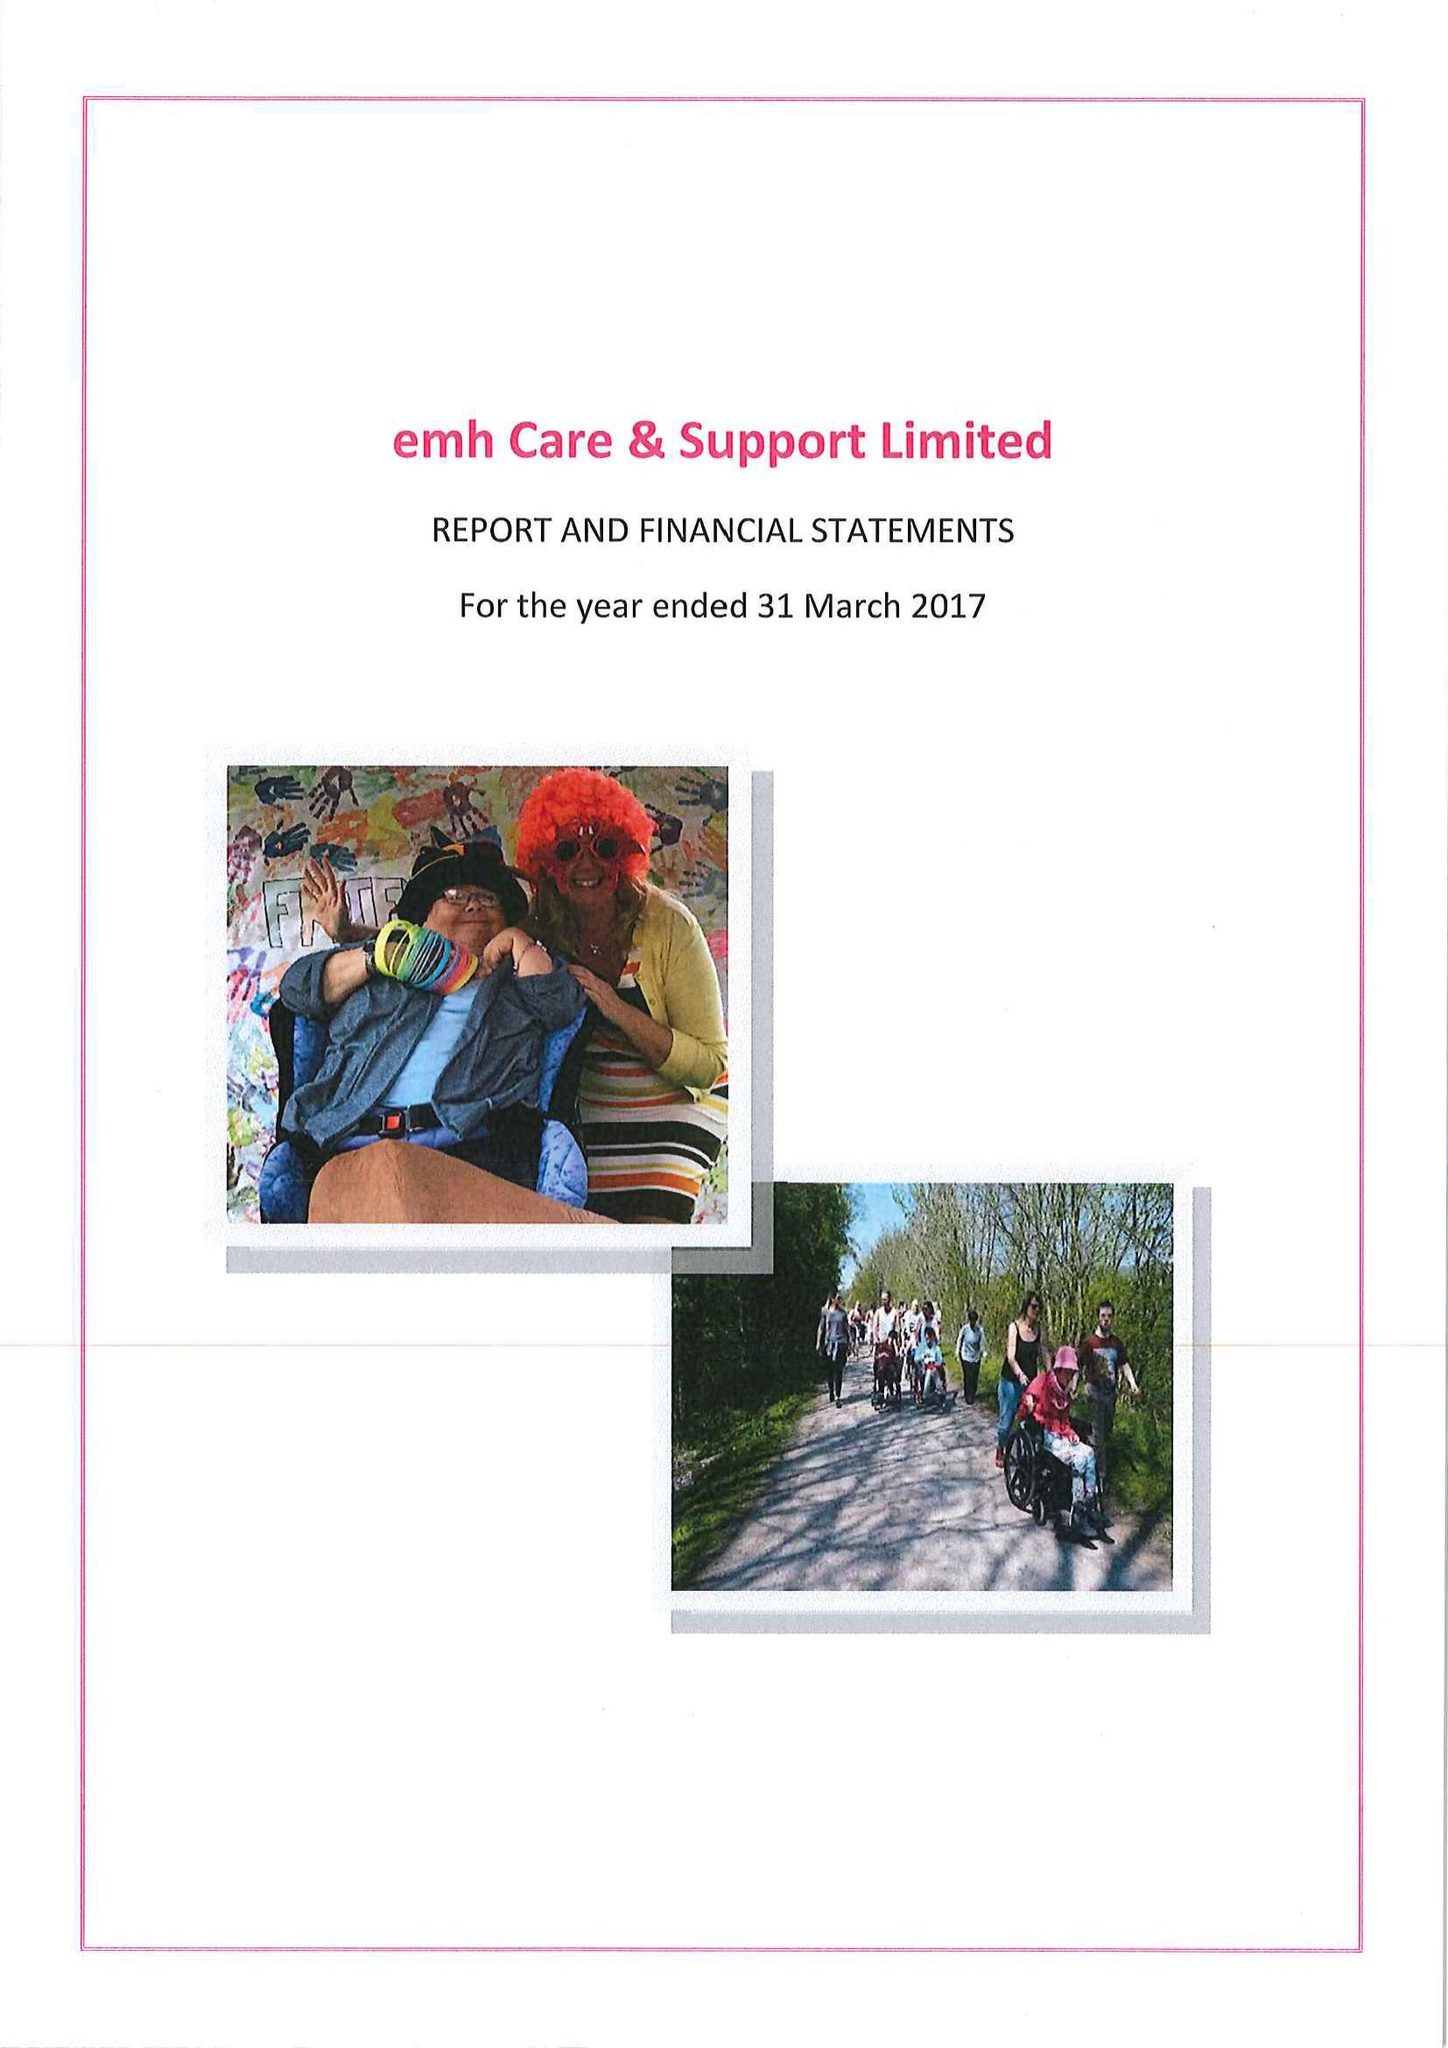What is the value for the charity_number?
Answer the question using a single word or phrase. 1001704 